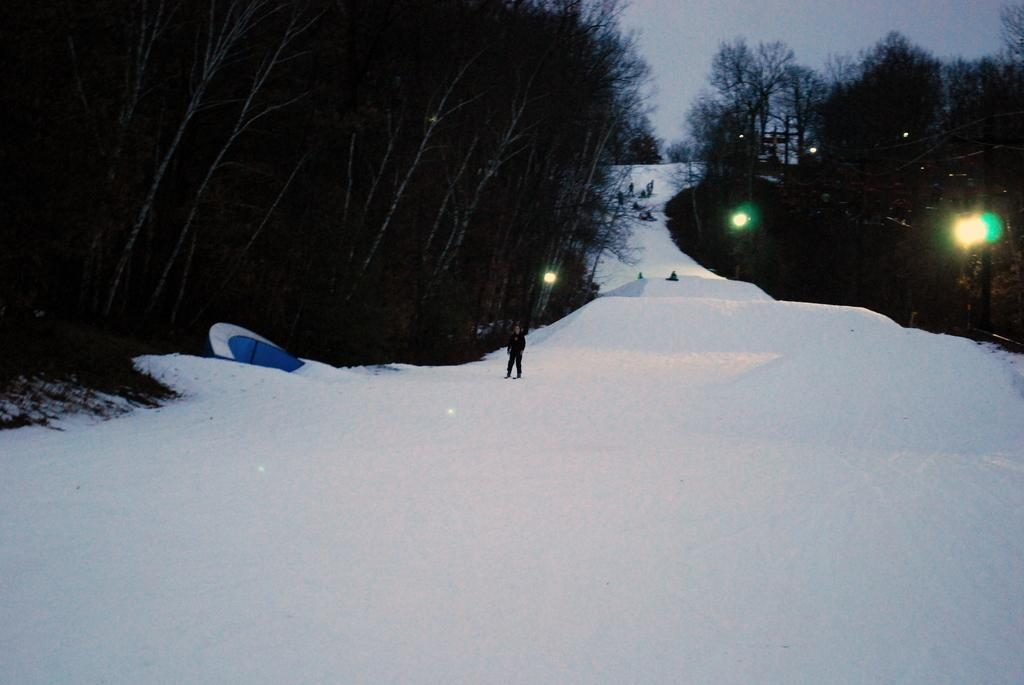What is the main feature in the center of the image? There is snow in the center of the image. What can be seen on both sides of the image? There are trees on both sides of the image. What is visible at the top of the image? The sky is visible at the top of the image. What type of town can be seen in the background of the image? There is no town visible in the image; it primarily features snow, trees, and the sky. 